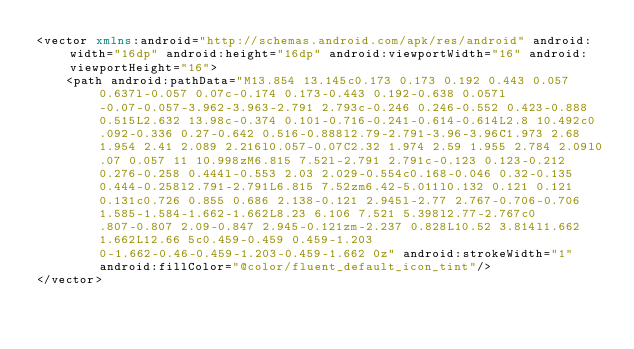Convert code to text. <code><loc_0><loc_0><loc_500><loc_500><_XML_><vector xmlns:android="http://schemas.android.com/apk/res/android" android:width="16dp" android:height="16dp" android:viewportWidth="16" android:viewportHeight="16">
    <path android:pathData="M13.854 13.145c0.173 0.173 0.192 0.443 0.057 0.637l-0.057 0.07c-0.174 0.173-0.443 0.192-0.638 0.057l-0.07-0.057-3.962-3.963-2.791 2.793c-0.246 0.246-0.552 0.423-0.888 0.515L2.632 13.98c-0.374 0.101-0.716-0.241-0.614-0.614L2.8 10.492c0.092-0.336 0.27-0.642 0.516-0.888l2.79-2.791-3.96-3.96C1.973 2.68 1.954 2.41 2.089 2.216l0.057-0.07C2.32 1.974 2.59 1.955 2.784 2.09l0.07 0.057 11 10.998zM6.815 7.52l-2.791 2.791c-0.123 0.123-0.212 0.276-0.258 0.444l-0.553 2.03 2.029-0.554c0.168-0.046 0.32-0.135 0.444-0.258l2.791-2.791L6.815 7.52zm6.42-5.011l0.132 0.121 0.121 0.131c0.726 0.855 0.686 2.138-0.121 2.945l-2.77 2.767-0.706-0.706 1.585-1.584-1.662-1.662L8.23 6.106 7.521 5.398l2.77-2.767c0.807-0.807 2.09-0.847 2.945-0.121zm-2.237 0.828L10.52 3.814l1.662 1.662L12.66 5c0.459-0.459 0.459-1.203 0-1.662-0.46-0.459-1.203-0.459-1.662 0z" android:strokeWidth="1" android:fillColor="@color/fluent_default_icon_tint"/>
</vector>
</code> 